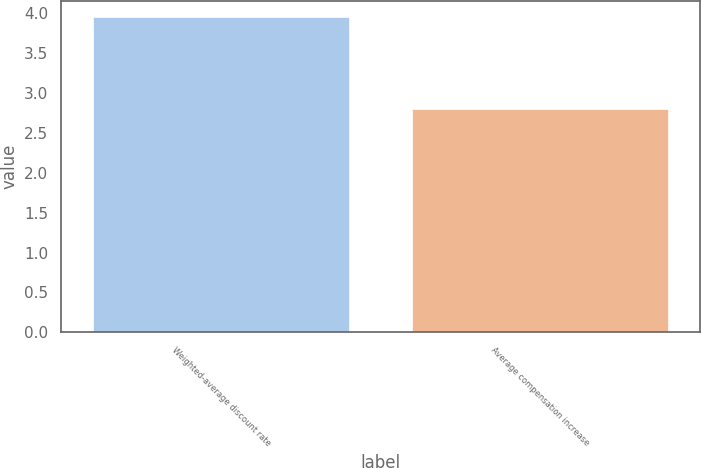Convert chart. <chart><loc_0><loc_0><loc_500><loc_500><bar_chart><fcel>Weighted-average discount rate<fcel>Average compensation increase<nl><fcel>3.95<fcel>2.8<nl></chart> 